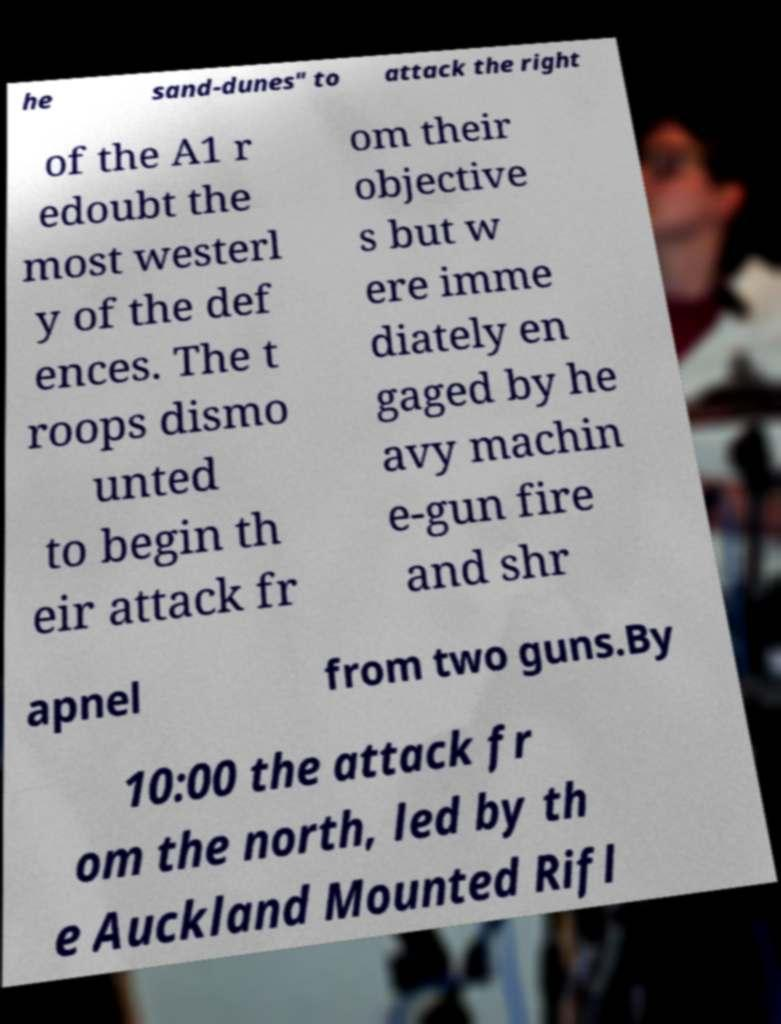Can you read and provide the text displayed in the image?This photo seems to have some interesting text. Can you extract and type it out for me? he sand-dunes" to attack the right of the A1 r edoubt the most westerl y of the def ences. The t roops dismo unted to begin th eir attack fr om their objective s but w ere imme diately en gaged by he avy machin e-gun fire and shr apnel from two guns.By 10:00 the attack fr om the north, led by th e Auckland Mounted Rifl 